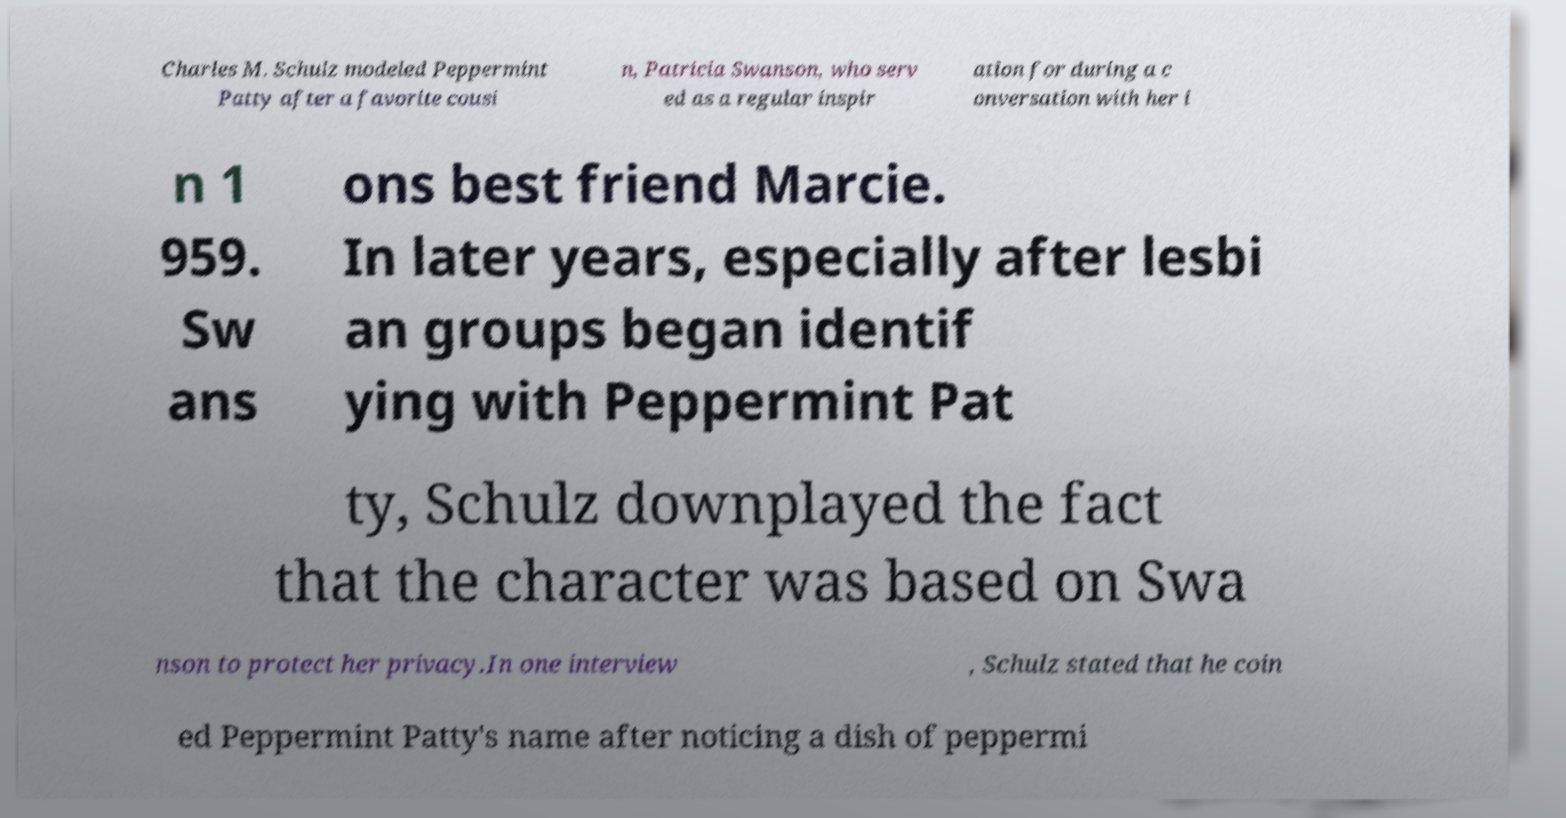Can you read and provide the text displayed in the image?This photo seems to have some interesting text. Can you extract and type it out for me? Charles M. Schulz modeled Peppermint Patty after a favorite cousi n, Patricia Swanson, who serv ed as a regular inspir ation for during a c onversation with her i n 1 959. Sw ans ons best friend Marcie. In later years, especially after lesbi an groups began identif ying with Peppermint Pat ty, Schulz downplayed the fact that the character was based on Swa nson to protect her privacy.In one interview , Schulz stated that he coin ed Peppermint Patty's name after noticing a dish of peppermi 